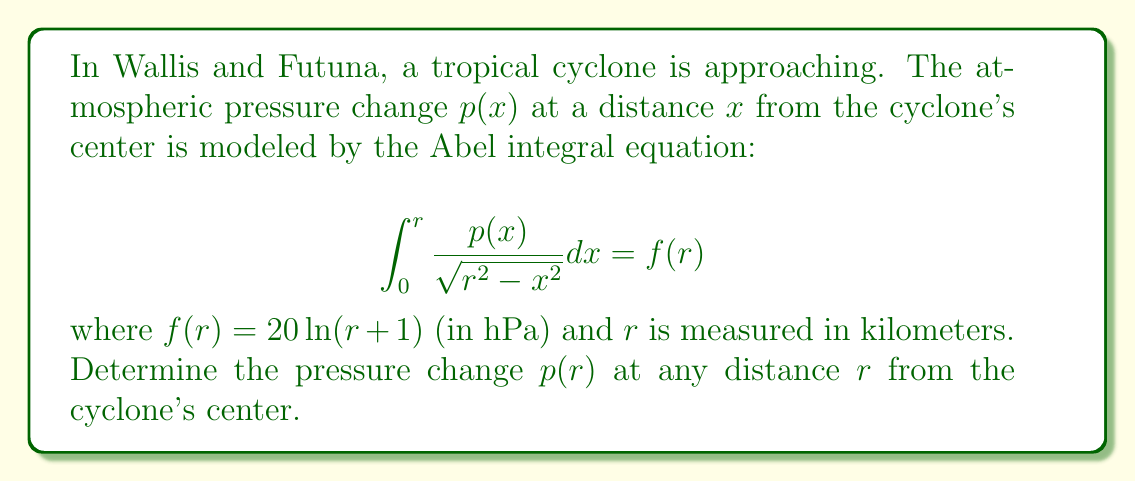Can you answer this question? To solve this Abel integral equation, we'll follow these steps:

1) The general solution to an Abel integral equation of the form:

   $$\int_0^r \frac{p(x)}{\sqrt{r^2 - x^2}} dx = f(r)$$

   is given by:

   $$p(r) = \frac{1}{\pi} \frac{d}{dr} \int_0^r \frac{f(x)}{\sqrt{r^2 - x^2}} dx$$

2) In our case, $f(r) = 20\ln(r+1)$. Let's substitute this into the solution:

   $$p(r) = \frac{1}{\pi} \frac{d}{dr} \int_0^r \frac{20\ln(x+1)}{\sqrt{r^2 - x^2}} dx$$

3) To evaluate this, we need to use the substitution $x = r\sin\theta$. This gives:

   $$p(r) = \frac{20}{\pi} \frac{d}{dr} \int_0^{\pi/2} \ln(r\sin\theta + 1) d\theta$$

4) Differentiating under the integral sign:

   $$p(r) = \frac{20}{\pi} \int_0^{\pi/2} \frac{\sin\theta}{r\sin\theta + 1} d\theta$$

5) This integral doesn't have a simple closed form, but it can be evaluated numerically for any given value of $r$.

6) We can simplify the expression slightly:

   $$p(r) = \frac{20}{\pi r} \int_0^{\pi/2} \frac{\sin\theta}{\frac{1}{r} + \sin\theta} d\theta$$

This is the final form of our solution for $p(r)$.
Answer: $$p(r) = \frac{20}{\pi r} \int_0^{\pi/2} \frac{\sin\theta}{\frac{1}{r} + \sin\theta} d\theta$$ 